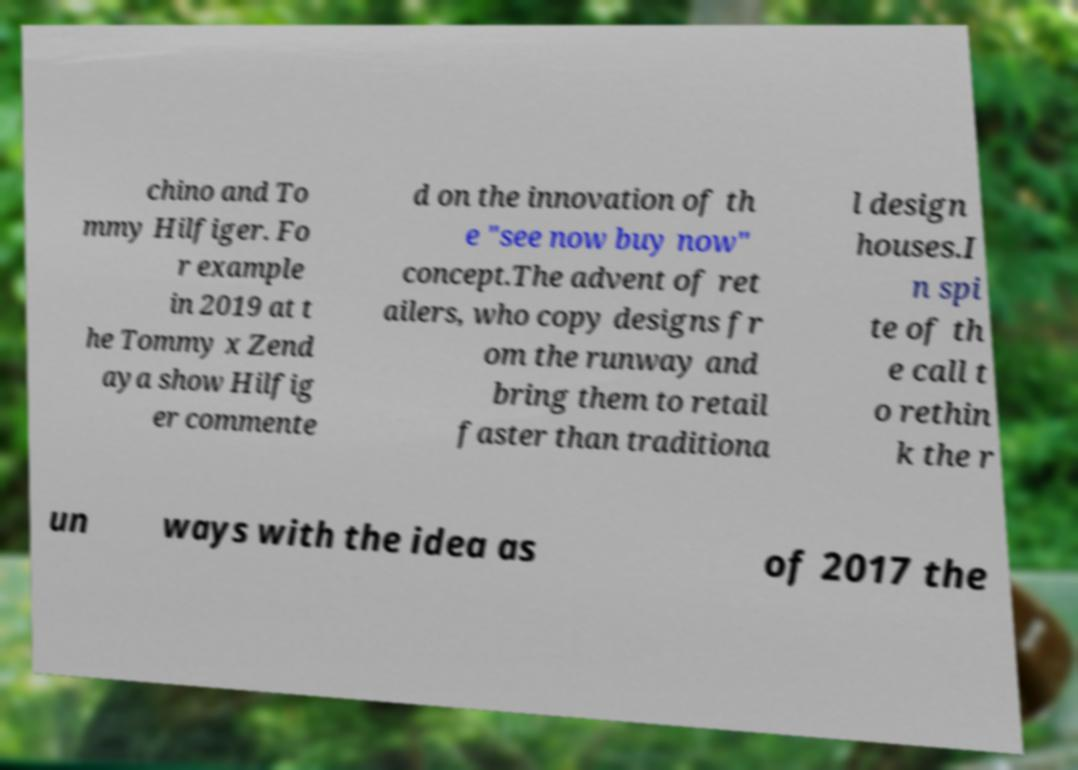Can you accurately transcribe the text from the provided image for me? chino and To mmy Hilfiger. Fo r example in 2019 at t he Tommy x Zend aya show Hilfig er commente d on the innovation of th e "see now buy now" concept.The advent of ret ailers, who copy designs fr om the runway and bring them to retail faster than traditiona l design houses.I n spi te of th e call t o rethin k the r un ways with the idea as of 2017 the 